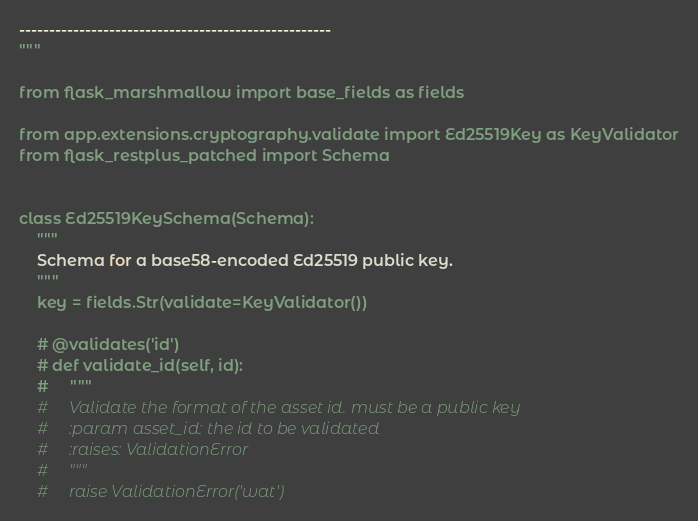Convert code to text. <code><loc_0><loc_0><loc_500><loc_500><_Python_>----------------------------------------------------
"""

from flask_marshmallow import base_fields as fields

from app.extensions.cryptography.validate import Ed25519Key as KeyValidator
from flask_restplus_patched import Schema


class Ed25519KeySchema(Schema):
    """
    Schema for a base58-encoded Ed25519 public key.
    """
    key = fields.Str(validate=KeyValidator())

    # @validates('id')
    # def validate_id(self, id):
    #     """
    #     Validate the format of the asset id. must be a public key
    #     :param asset_id: the id to be validated
    #     :raises: ValidationError
    #     """
    #     raise ValidationError('wat')
</code> 